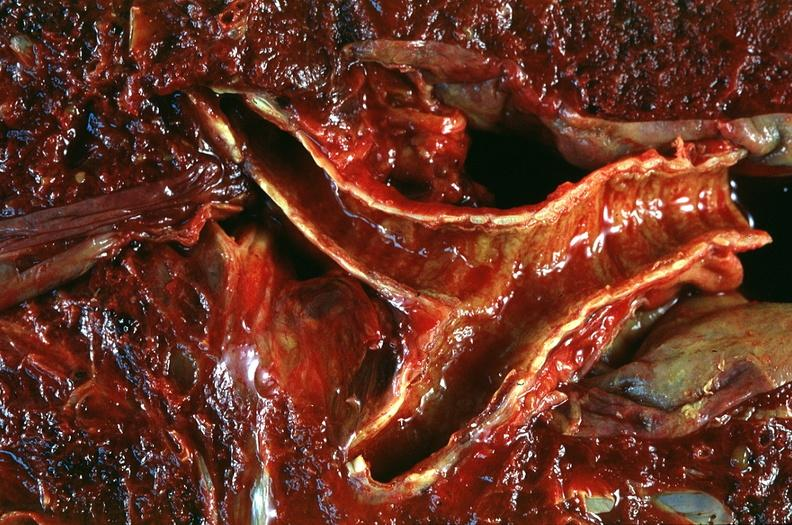s respiratory present?
Answer the question using a single word or phrase. Yes 